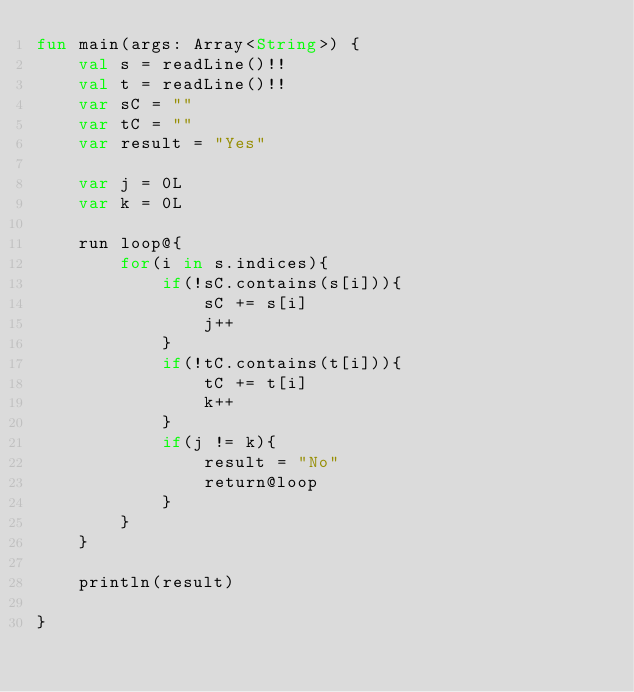<code> <loc_0><loc_0><loc_500><loc_500><_Kotlin_>fun main(args: Array<String>) {
    val s = readLine()!!
    val t = readLine()!!
    var sC = ""
    var tC = ""
    var result = "Yes"

    var j = 0L
    var k = 0L

    run loop@{
        for(i in s.indices){
            if(!sC.contains(s[i])){
                sC += s[i]
                j++
            }
            if(!tC.contains(t[i])){
                tC += t[i]
                k++
            }
            if(j != k){
                result = "No"
                return@loop
            }
        }
    }

    println(result)

}</code> 